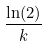Convert formula to latex. <formula><loc_0><loc_0><loc_500><loc_500>\frac { \ln ( 2 ) } { k }</formula> 